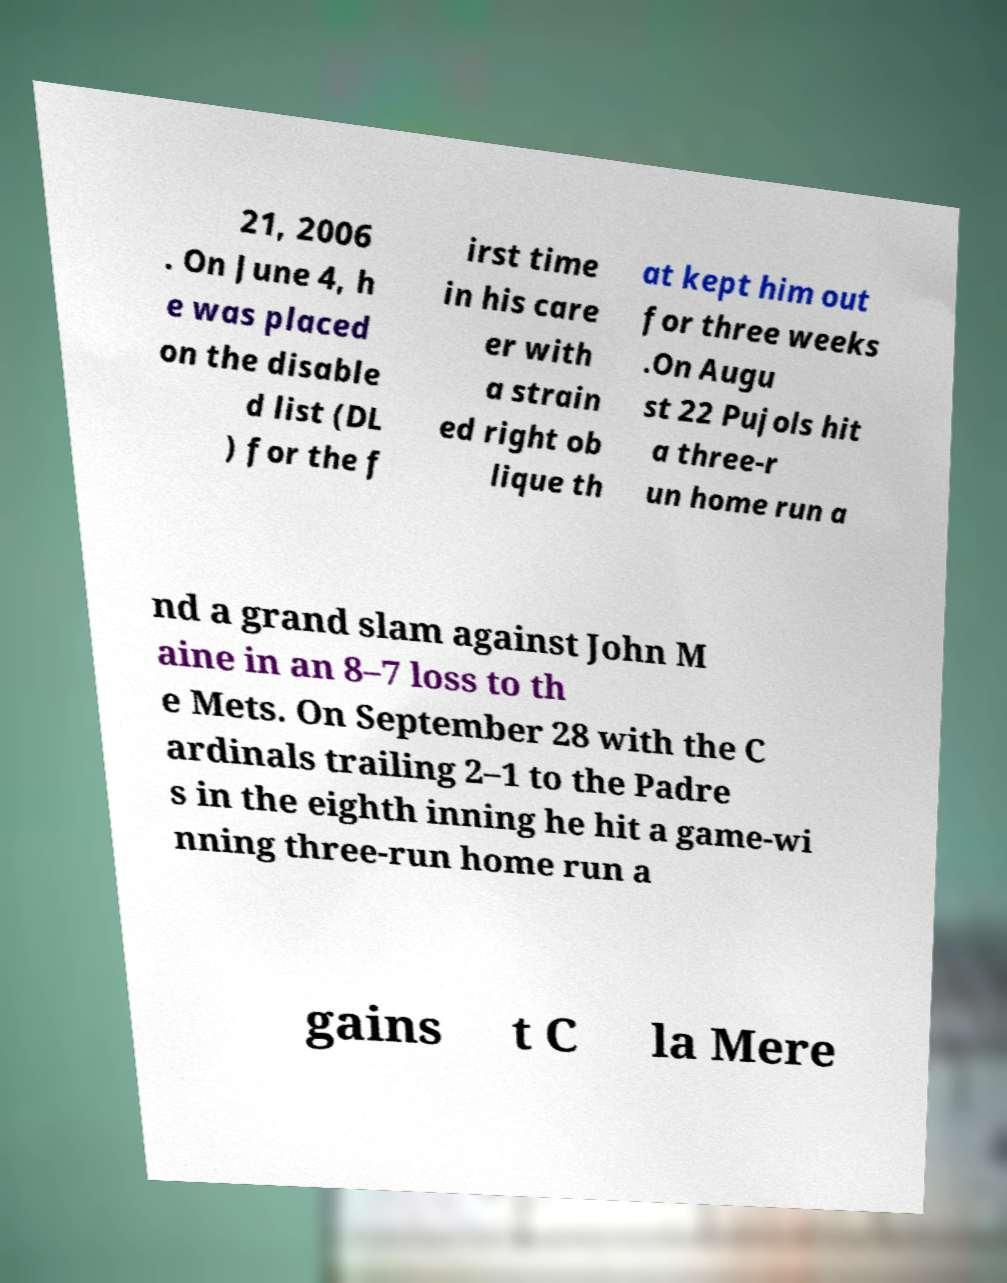Could you assist in decoding the text presented in this image and type it out clearly? 21, 2006 . On June 4, h e was placed on the disable d list (DL ) for the f irst time in his care er with a strain ed right ob lique th at kept him out for three weeks .On Augu st 22 Pujols hit a three-r un home run a nd a grand slam against John M aine in an 8–7 loss to th e Mets. On September 28 with the C ardinals trailing 2–1 to the Padre s in the eighth inning he hit a game-wi nning three-run home run a gains t C la Mere 